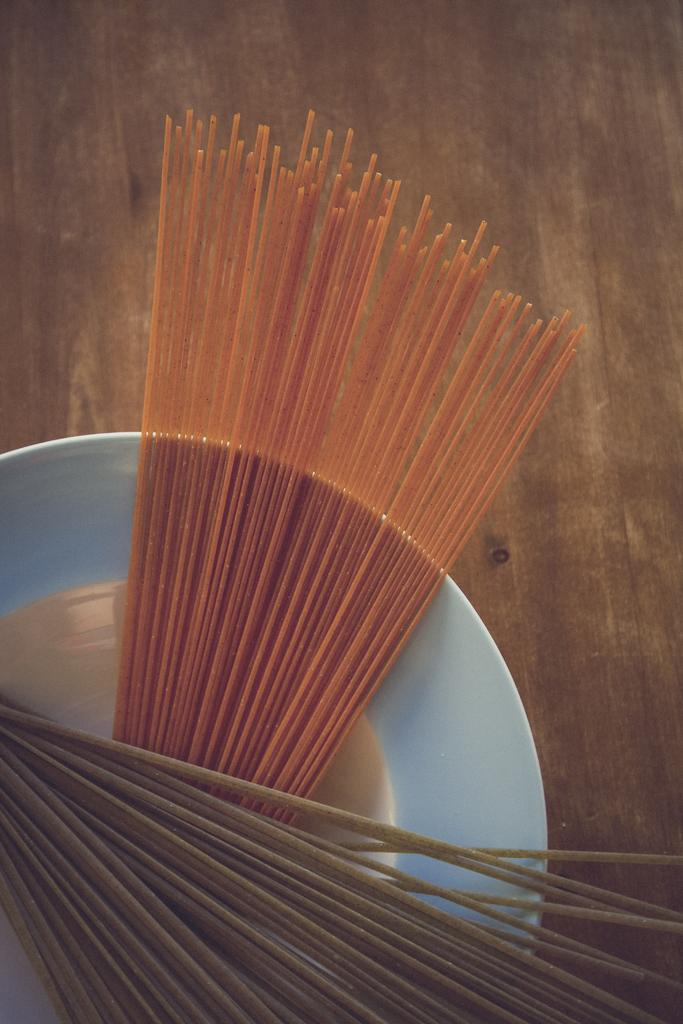What is on the plate in the image? The plate contains sticks in the image. What can be observed about the sticks on the plate? The sticks have two different colors. How many basketballs can be seen on the plate in the image? There are no basketballs present on the plate in the image; it contains sticks with two different colors. 